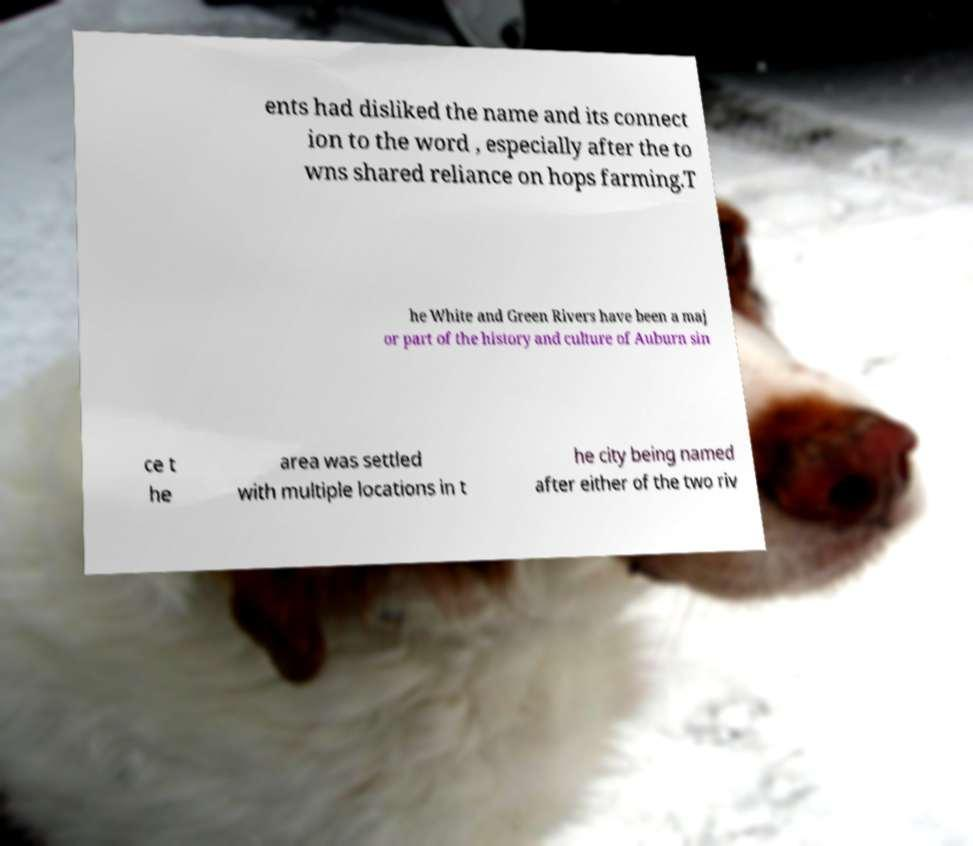Can you accurately transcribe the text from the provided image for me? ents had disliked the name and its connect ion to the word , especially after the to wns shared reliance on hops farming.T he White and Green Rivers have been a maj or part of the history and culture of Auburn sin ce t he area was settled with multiple locations in t he city being named after either of the two riv 